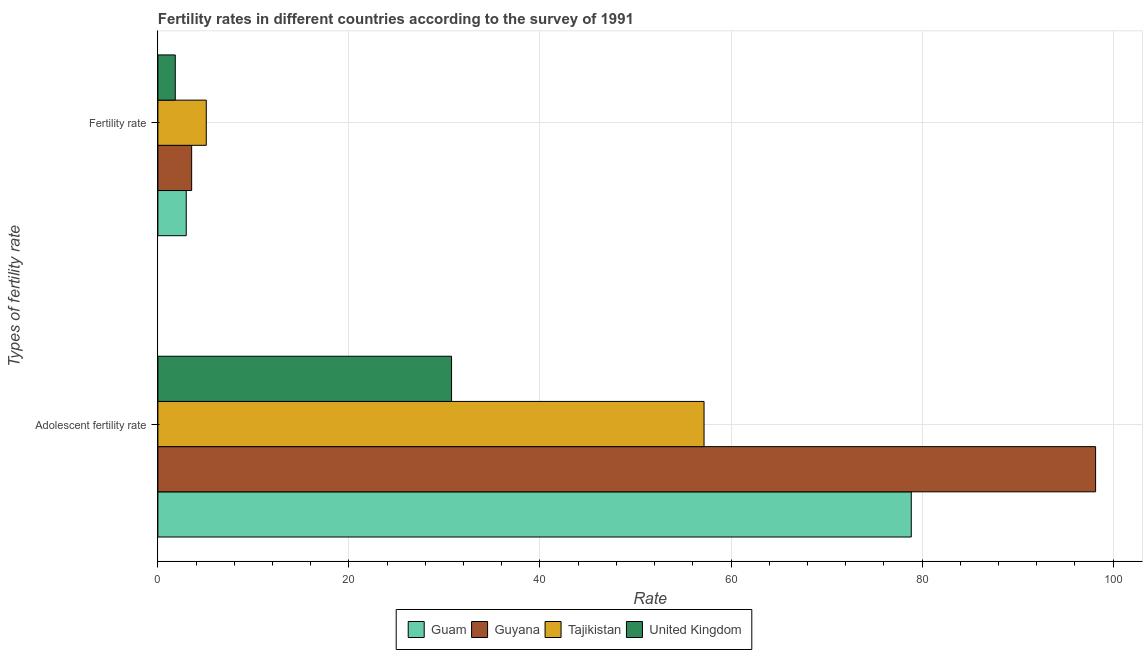How many groups of bars are there?
Keep it short and to the point. 2. Are the number of bars per tick equal to the number of legend labels?
Offer a terse response. Yes. How many bars are there on the 2nd tick from the top?
Ensure brevity in your answer.  4. What is the label of the 2nd group of bars from the top?
Your answer should be compact. Adolescent fertility rate. What is the adolescent fertility rate in United Kingdom?
Give a very brief answer. 30.74. Across all countries, what is the maximum fertility rate?
Give a very brief answer. 5.07. Across all countries, what is the minimum fertility rate?
Make the answer very short. 1.82. In which country was the adolescent fertility rate maximum?
Keep it short and to the point. Guyana. What is the total adolescent fertility rate in the graph?
Keep it short and to the point. 264.97. What is the difference between the adolescent fertility rate in United Kingdom and that in Guam?
Offer a terse response. -48.13. What is the difference between the adolescent fertility rate in United Kingdom and the fertility rate in Tajikistan?
Offer a very short reply. 25.68. What is the average adolescent fertility rate per country?
Make the answer very short. 66.24. What is the difference between the adolescent fertility rate and fertility rate in United Kingdom?
Provide a short and direct response. 28.92. In how many countries, is the fertility rate greater than 24 ?
Keep it short and to the point. 0. What is the ratio of the fertility rate in Guyana to that in Tajikistan?
Ensure brevity in your answer.  0.7. What does the 2nd bar from the bottom in Fertility rate represents?
Offer a very short reply. Guyana. Are all the bars in the graph horizontal?
Keep it short and to the point. Yes. How many countries are there in the graph?
Your response must be concise. 4. What is the difference between two consecutive major ticks on the X-axis?
Your answer should be compact. 20. Are the values on the major ticks of X-axis written in scientific E-notation?
Ensure brevity in your answer.  No. Where does the legend appear in the graph?
Your response must be concise. Bottom center. What is the title of the graph?
Offer a very short reply. Fertility rates in different countries according to the survey of 1991. What is the label or title of the X-axis?
Provide a succinct answer. Rate. What is the label or title of the Y-axis?
Provide a succinct answer. Types of fertility rate. What is the Rate of Guam in Adolescent fertility rate?
Make the answer very short. 78.87. What is the Rate in Guyana in Adolescent fertility rate?
Provide a short and direct response. 98.17. What is the Rate in Tajikistan in Adolescent fertility rate?
Offer a very short reply. 57.18. What is the Rate in United Kingdom in Adolescent fertility rate?
Offer a terse response. 30.74. What is the Rate in Guam in Fertility rate?
Your response must be concise. 2.97. What is the Rate of Guyana in Fertility rate?
Your response must be concise. 3.54. What is the Rate in Tajikistan in Fertility rate?
Provide a short and direct response. 5.07. What is the Rate in United Kingdom in Fertility rate?
Your answer should be compact. 1.82. Across all Types of fertility rate, what is the maximum Rate of Guam?
Ensure brevity in your answer.  78.87. Across all Types of fertility rate, what is the maximum Rate in Guyana?
Your answer should be compact. 98.17. Across all Types of fertility rate, what is the maximum Rate in Tajikistan?
Ensure brevity in your answer.  57.18. Across all Types of fertility rate, what is the maximum Rate in United Kingdom?
Offer a terse response. 30.74. Across all Types of fertility rate, what is the minimum Rate in Guam?
Your answer should be very brief. 2.97. Across all Types of fertility rate, what is the minimum Rate of Guyana?
Your answer should be very brief. 3.54. Across all Types of fertility rate, what is the minimum Rate in Tajikistan?
Ensure brevity in your answer.  5.07. Across all Types of fertility rate, what is the minimum Rate in United Kingdom?
Your response must be concise. 1.82. What is the total Rate of Guam in the graph?
Keep it short and to the point. 81.84. What is the total Rate in Guyana in the graph?
Provide a short and direct response. 101.71. What is the total Rate of Tajikistan in the graph?
Make the answer very short. 62.25. What is the total Rate of United Kingdom in the graph?
Your answer should be very brief. 32.56. What is the difference between the Rate of Guam in Adolescent fertility rate and that in Fertility rate?
Make the answer very short. 75.9. What is the difference between the Rate of Guyana in Adolescent fertility rate and that in Fertility rate?
Offer a terse response. 94.64. What is the difference between the Rate of Tajikistan in Adolescent fertility rate and that in Fertility rate?
Your response must be concise. 52.11. What is the difference between the Rate of United Kingdom in Adolescent fertility rate and that in Fertility rate?
Provide a succinct answer. 28.92. What is the difference between the Rate of Guam in Adolescent fertility rate and the Rate of Guyana in Fertility rate?
Offer a terse response. 75.34. What is the difference between the Rate of Guam in Adolescent fertility rate and the Rate of Tajikistan in Fertility rate?
Offer a terse response. 73.81. What is the difference between the Rate of Guam in Adolescent fertility rate and the Rate of United Kingdom in Fertility rate?
Offer a terse response. 77.05. What is the difference between the Rate in Guyana in Adolescent fertility rate and the Rate in Tajikistan in Fertility rate?
Provide a succinct answer. 93.11. What is the difference between the Rate in Guyana in Adolescent fertility rate and the Rate in United Kingdom in Fertility rate?
Give a very brief answer. 96.35. What is the difference between the Rate in Tajikistan in Adolescent fertility rate and the Rate in United Kingdom in Fertility rate?
Ensure brevity in your answer.  55.36. What is the average Rate in Guam per Types of fertility rate?
Your response must be concise. 40.92. What is the average Rate in Guyana per Types of fertility rate?
Your response must be concise. 50.85. What is the average Rate in Tajikistan per Types of fertility rate?
Give a very brief answer. 31.12. What is the average Rate of United Kingdom per Types of fertility rate?
Offer a terse response. 16.28. What is the difference between the Rate of Guam and Rate of Guyana in Adolescent fertility rate?
Your answer should be very brief. -19.3. What is the difference between the Rate in Guam and Rate in Tajikistan in Adolescent fertility rate?
Your answer should be compact. 21.69. What is the difference between the Rate in Guam and Rate in United Kingdom in Adolescent fertility rate?
Keep it short and to the point. 48.13. What is the difference between the Rate in Guyana and Rate in Tajikistan in Adolescent fertility rate?
Your response must be concise. 40.99. What is the difference between the Rate in Guyana and Rate in United Kingdom in Adolescent fertility rate?
Make the answer very short. 67.43. What is the difference between the Rate of Tajikistan and Rate of United Kingdom in Adolescent fertility rate?
Your answer should be very brief. 26.44. What is the difference between the Rate of Guam and Rate of Guyana in Fertility rate?
Your answer should be compact. -0.57. What is the difference between the Rate in Guam and Rate in Tajikistan in Fertility rate?
Your answer should be very brief. -2.1. What is the difference between the Rate in Guam and Rate in United Kingdom in Fertility rate?
Give a very brief answer. 1.15. What is the difference between the Rate of Guyana and Rate of Tajikistan in Fertility rate?
Provide a short and direct response. -1.53. What is the difference between the Rate of Guyana and Rate of United Kingdom in Fertility rate?
Your response must be concise. 1.72. What is the difference between the Rate of Tajikistan and Rate of United Kingdom in Fertility rate?
Provide a succinct answer. 3.25. What is the ratio of the Rate of Guam in Adolescent fertility rate to that in Fertility rate?
Provide a succinct answer. 26.57. What is the ratio of the Rate of Guyana in Adolescent fertility rate to that in Fertility rate?
Ensure brevity in your answer.  27.77. What is the ratio of the Rate of Tajikistan in Adolescent fertility rate to that in Fertility rate?
Give a very brief answer. 11.28. What is the ratio of the Rate of United Kingdom in Adolescent fertility rate to that in Fertility rate?
Provide a short and direct response. 16.89. What is the difference between the highest and the second highest Rate in Guam?
Your answer should be compact. 75.9. What is the difference between the highest and the second highest Rate in Guyana?
Provide a succinct answer. 94.64. What is the difference between the highest and the second highest Rate of Tajikistan?
Give a very brief answer. 52.11. What is the difference between the highest and the second highest Rate in United Kingdom?
Keep it short and to the point. 28.92. What is the difference between the highest and the lowest Rate of Guam?
Offer a terse response. 75.9. What is the difference between the highest and the lowest Rate in Guyana?
Give a very brief answer. 94.64. What is the difference between the highest and the lowest Rate of Tajikistan?
Your answer should be very brief. 52.11. What is the difference between the highest and the lowest Rate of United Kingdom?
Your response must be concise. 28.92. 